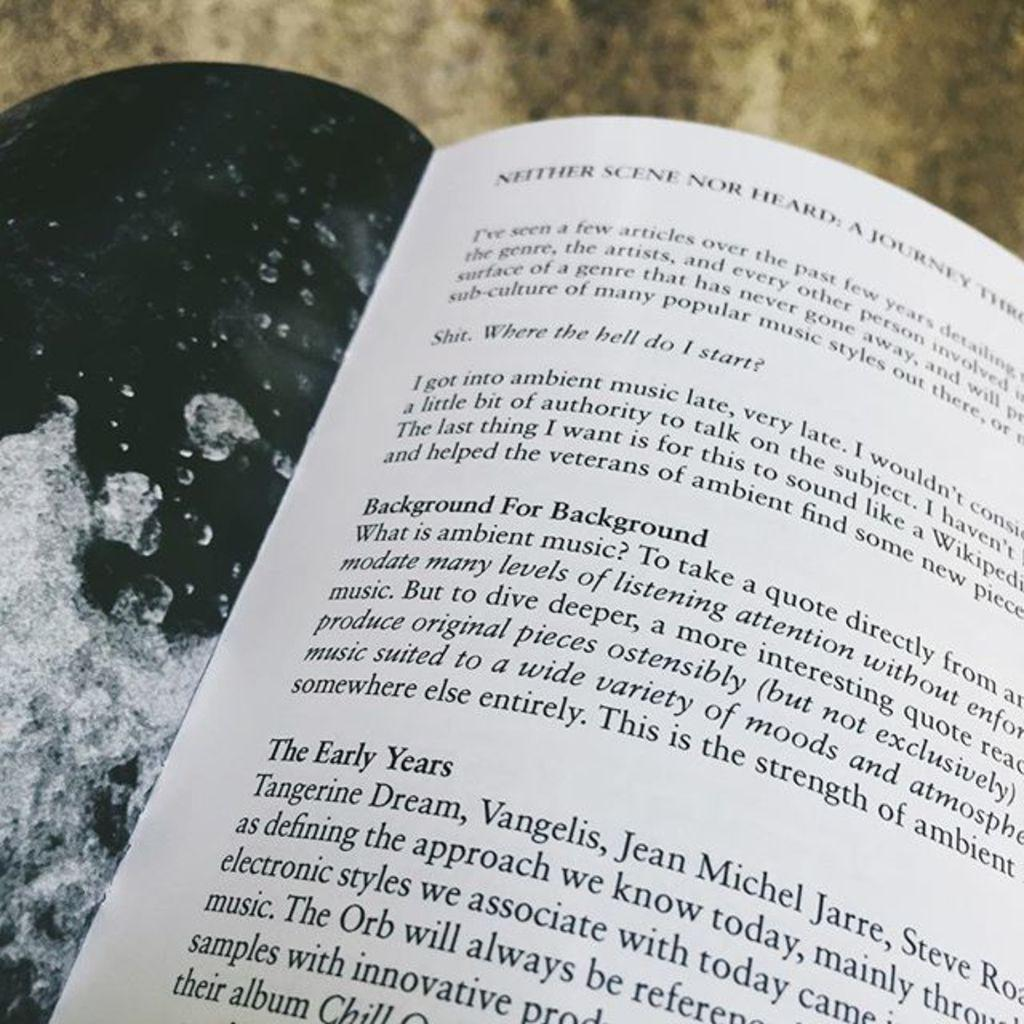<image>
Offer a succinct explanation of the picture presented. An open book on the neither scene nor heard chapter. 